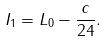<formula> <loc_0><loc_0><loc_500><loc_500>I _ { 1 } = L _ { 0 } - \frac { c } { 2 4 } .</formula> 